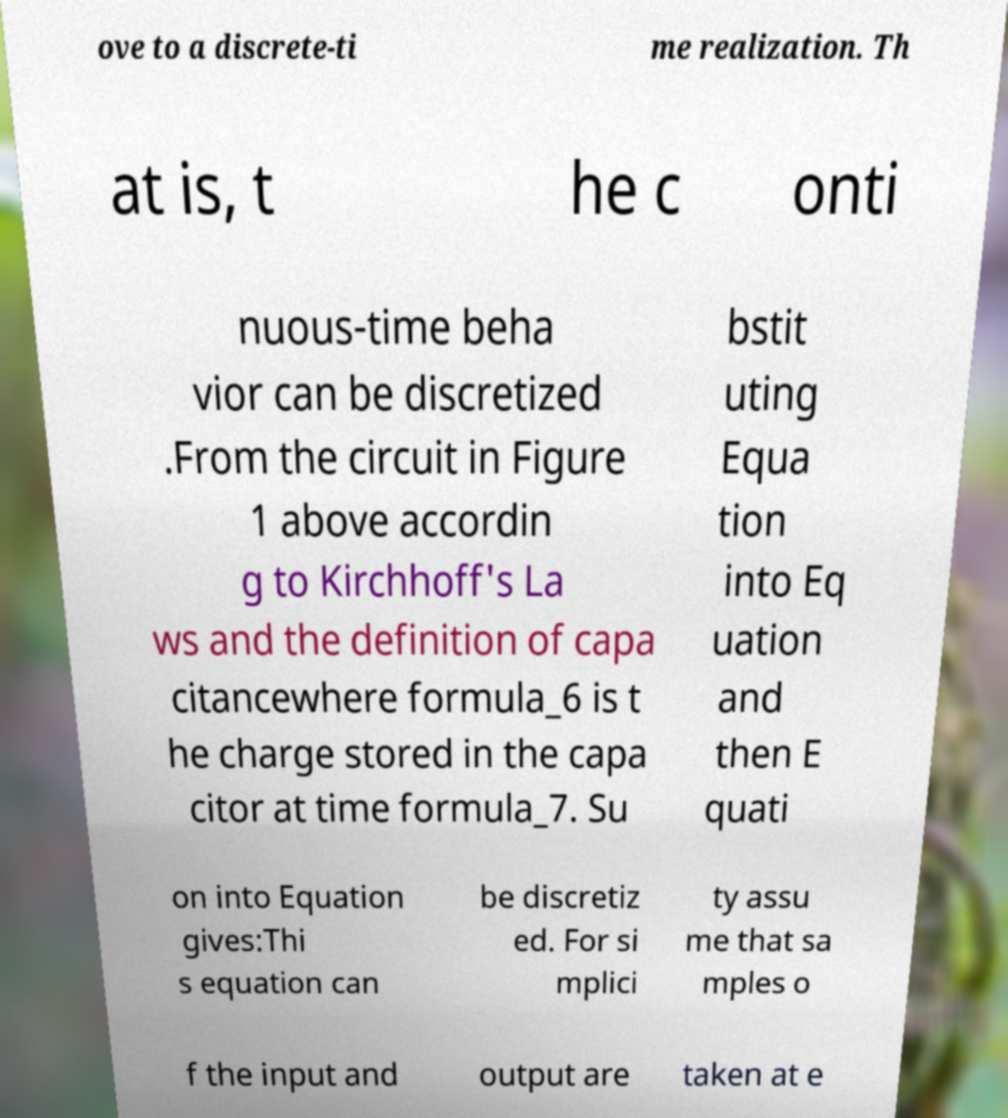I need the written content from this picture converted into text. Can you do that? ove to a discrete-ti me realization. Th at is, t he c onti nuous-time beha vior can be discretized .From the circuit in Figure 1 above accordin g to Kirchhoff's La ws and the definition of capa citancewhere formula_6 is t he charge stored in the capa citor at time formula_7. Su bstit uting Equa tion into Eq uation and then E quati on into Equation gives:Thi s equation can be discretiz ed. For si mplici ty assu me that sa mples o f the input and output are taken at e 